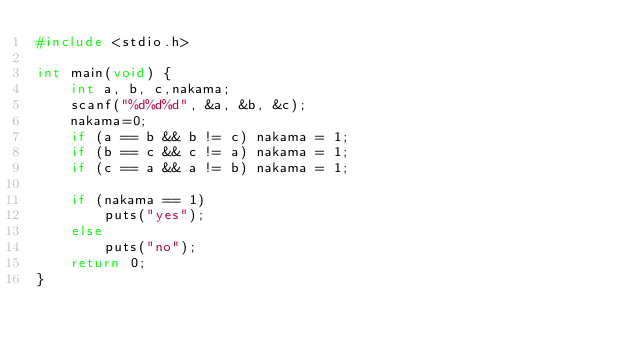Convert code to text. <code><loc_0><loc_0><loc_500><loc_500><_C_>#include <stdio.h>

int main(void) {
    int a, b, c,nakama;
    scanf("%d%d%d", &a, &b, &c);
    nakama=0;
    if (a == b && b != c) nakama = 1;
    if (b == c && c != a) nakama = 1; 
    if (c == a && a != b) nakama = 1;
    
    if (nakama == 1)
        puts("yes");
    else
        puts("no");
    return 0; 
}</code> 